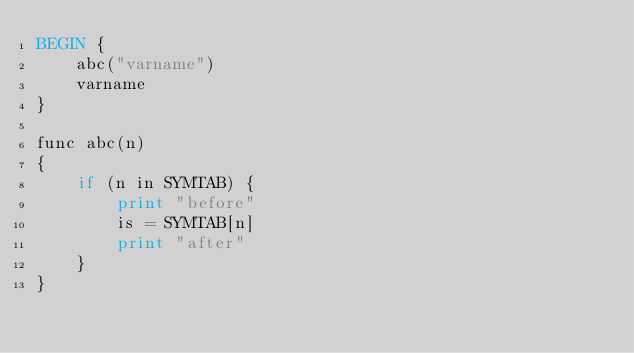<code> <loc_0><loc_0><loc_500><loc_500><_Awk_>BEGIN {
	abc("varname")
	varname
}

func abc(n)
{
	if (n in SYMTAB) {
		print "before"
		is = SYMTAB[n]
		print "after"
	}
}
</code> 